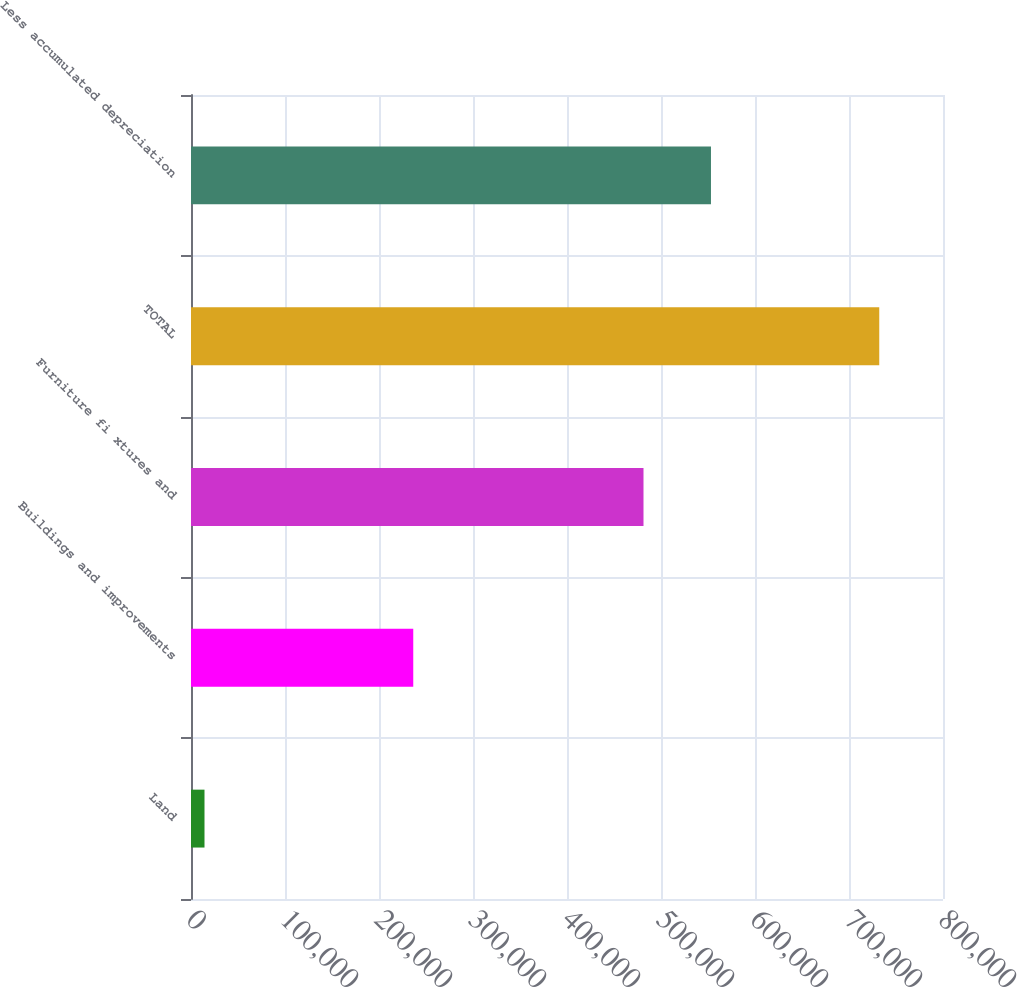<chart> <loc_0><loc_0><loc_500><loc_500><bar_chart><fcel>Land<fcel>Buildings and improvements<fcel>Furniture fi xtures and<fcel>TOTAL<fcel>Less accumulated depreciation<nl><fcel>14359<fcel>236444<fcel>481382<fcel>732185<fcel>553165<nl></chart> 